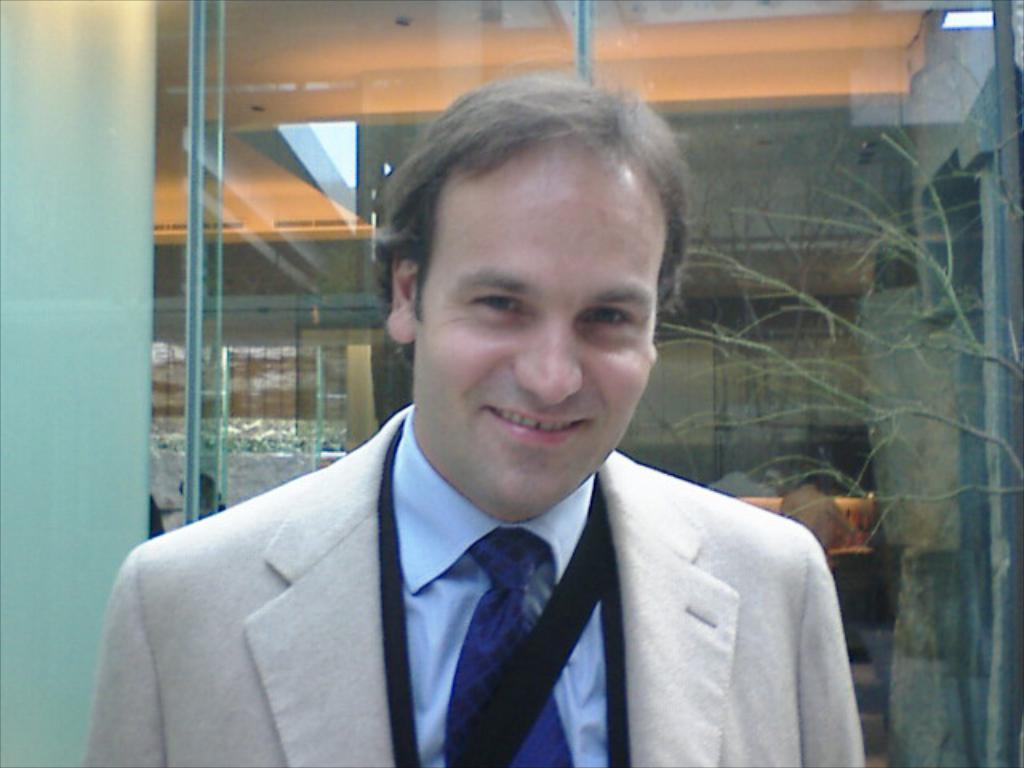What is the main subject of the image? There is a man in the image. What is the man doing in the image? The man is standing in the image. What is the man's facial expression in the image? The man is smiling in the image. What is the man wearing in the image? The man is wearing a white blazer, a tie, and a shirt in the image. What can be seen in the background of the image? There is a glass wall in the background of the image. What type of flesh can be seen on the man's skateboard in the image? There is no skateboard or flesh present in the image; the man is wearing a white blazer, a tie, and a shirt while standing in front of a glass wall. 